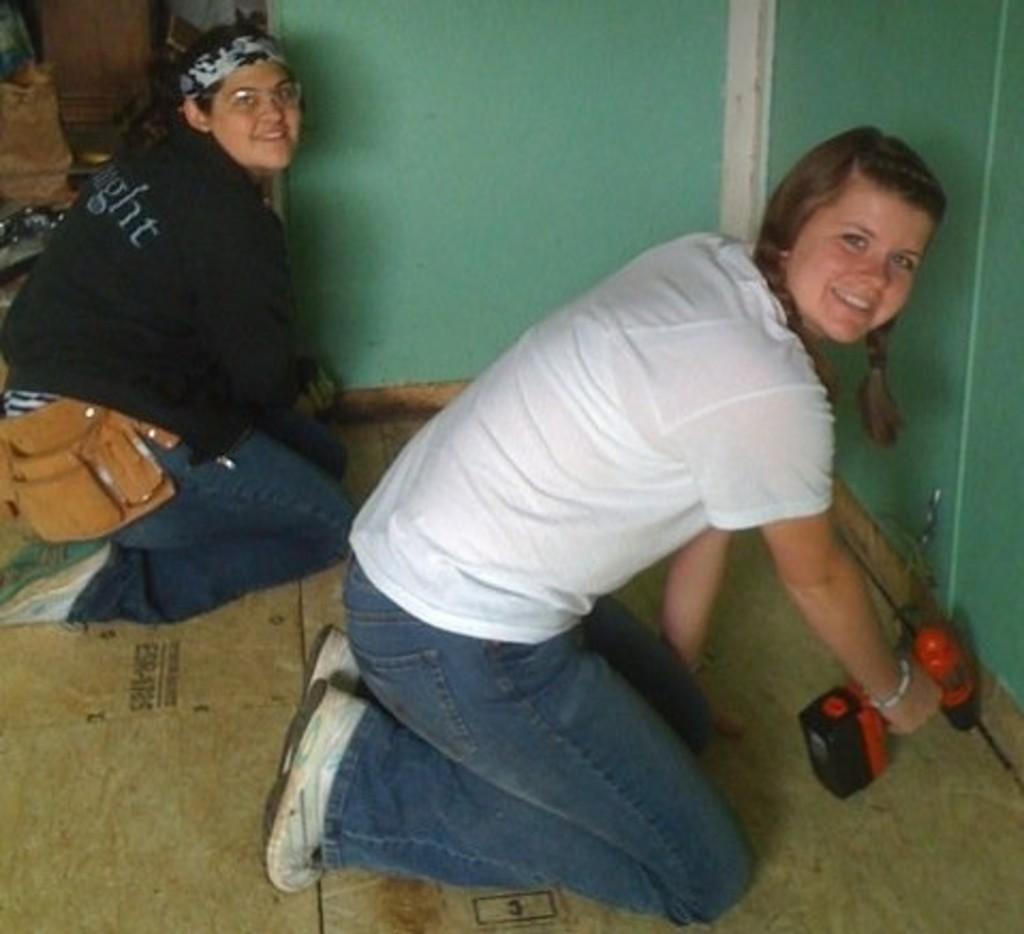In one or two sentences, can you explain what this image depicts? In this picture there are two girls wearing white and black color t- shirt, sitting on the ground and repairing the door with red color tool. Behind there is a green color wall and door. 